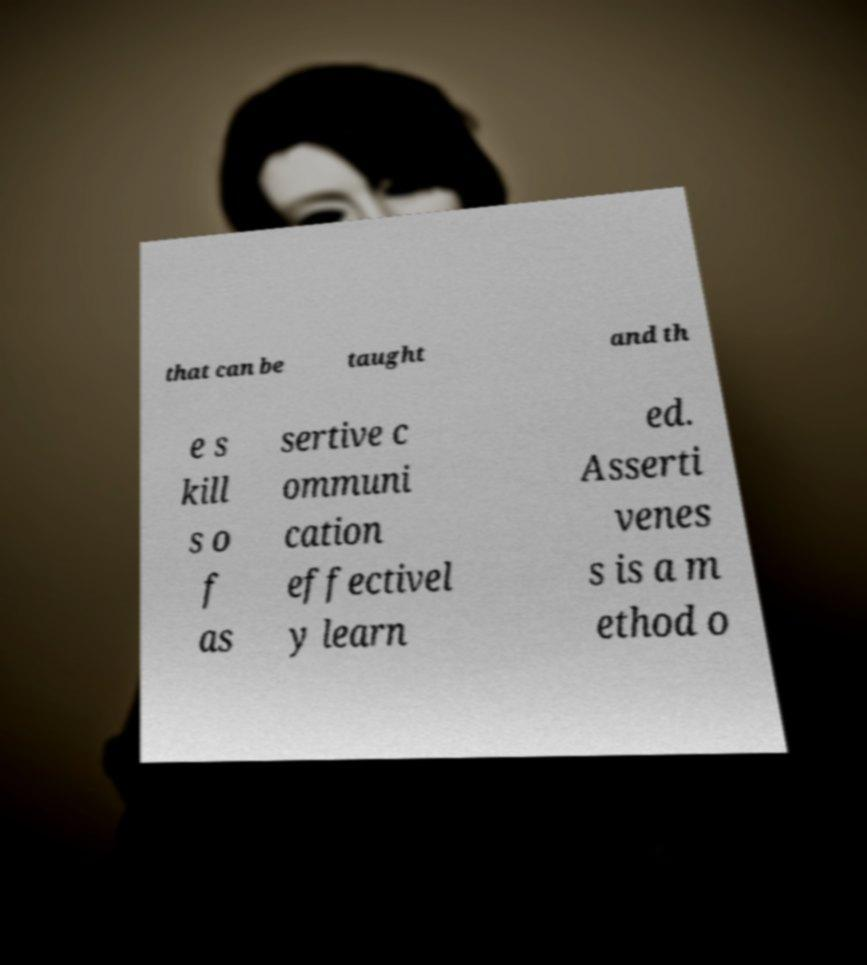For documentation purposes, I need the text within this image transcribed. Could you provide that? that can be taught and th e s kill s o f as sertive c ommuni cation effectivel y learn ed. Asserti venes s is a m ethod o 